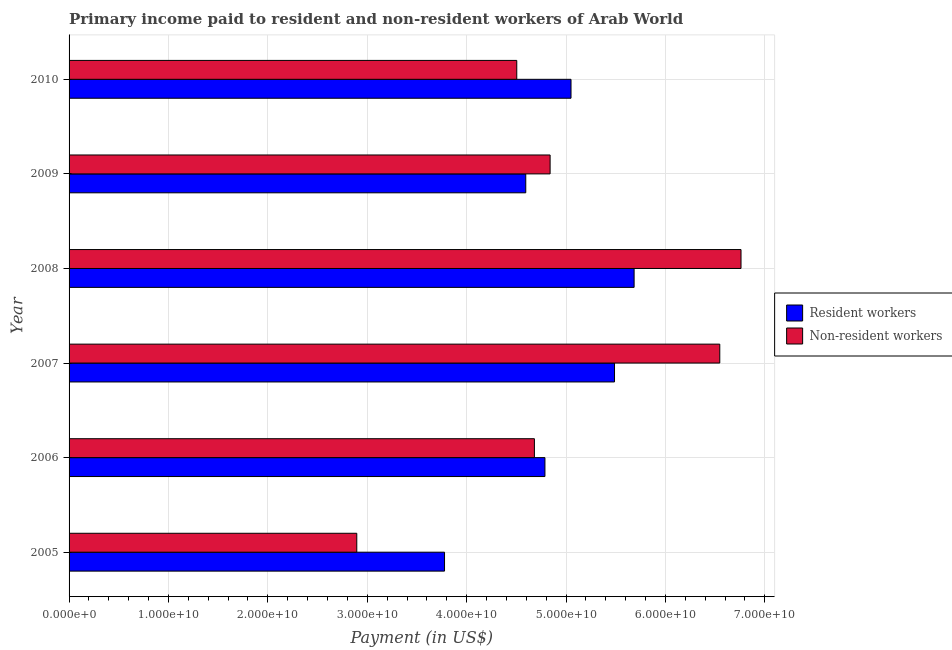How many groups of bars are there?
Offer a very short reply. 6. Are the number of bars on each tick of the Y-axis equal?
Give a very brief answer. Yes. What is the label of the 2nd group of bars from the top?
Give a very brief answer. 2009. What is the payment made to non-resident workers in 2009?
Offer a terse response. 4.84e+1. Across all years, what is the maximum payment made to resident workers?
Ensure brevity in your answer.  5.68e+1. Across all years, what is the minimum payment made to resident workers?
Keep it short and to the point. 3.78e+1. In which year was the payment made to resident workers maximum?
Offer a terse response. 2008. What is the total payment made to non-resident workers in the graph?
Your answer should be compact. 3.02e+11. What is the difference between the payment made to resident workers in 2006 and that in 2009?
Provide a short and direct response. 1.93e+09. What is the difference between the payment made to resident workers in 2008 and the payment made to non-resident workers in 2010?
Your response must be concise. 1.18e+1. What is the average payment made to non-resident workers per year?
Your response must be concise. 5.04e+1. In the year 2010, what is the difference between the payment made to resident workers and payment made to non-resident workers?
Ensure brevity in your answer.  5.46e+09. In how many years, is the payment made to resident workers greater than 12000000000 US$?
Ensure brevity in your answer.  6. What is the ratio of the payment made to resident workers in 2005 to that in 2008?
Ensure brevity in your answer.  0.66. What is the difference between the highest and the second highest payment made to resident workers?
Your answer should be very brief. 1.97e+09. What is the difference between the highest and the lowest payment made to resident workers?
Provide a succinct answer. 1.91e+1. In how many years, is the payment made to non-resident workers greater than the average payment made to non-resident workers taken over all years?
Ensure brevity in your answer.  2. Is the sum of the payment made to resident workers in 2005 and 2006 greater than the maximum payment made to non-resident workers across all years?
Keep it short and to the point. Yes. What does the 2nd bar from the top in 2008 represents?
Keep it short and to the point. Resident workers. What does the 1st bar from the bottom in 2010 represents?
Offer a very short reply. Resident workers. Are all the bars in the graph horizontal?
Offer a very short reply. Yes. What is the difference between two consecutive major ticks on the X-axis?
Make the answer very short. 1.00e+1. Does the graph contain any zero values?
Offer a very short reply. No. Where does the legend appear in the graph?
Offer a very short reply. Center right. What is the title of the graph?
Give a very brief answer. Primary income paid to resident and non-resident workers of Arab World. What is the label or title of the X-axis?
Make the answer very short. Payment (in US$). What is the label or title of the Y-axis?
Your answer should be compact. Year. What is the Payment (in US$) of Resident workers in 2005?
Your answer should be compact. 3.78e+1. What is the Payment (in US$) in Non-resident workers in 2005?
Provide a short and direct response. 2.89e+1. What is the Payment (in US$) of Resident workers in 2006?
Your answer should be very brief. 4.79e+1. What is the Payment (in US$) of Non-resident workers in 2006?
Provide a succinct answer. 4.68e+1. What is the Payment (in US$) of Resident workers in 2007?
Keep it short and to the point. 5.49e+1. What is the Payment (in US$) of Non-resident workers in 2007?
Your answer should be very brief. 6.55e+1. What is the Payment (in US$) in Resident workers in 2008?
Your answer should be compact. 5.68e+1. What is the Payment (in US$) of Non-resident workers in 2008?
Give a very brief answer. 6.76e+1. What is the Payment (in US$) in Resident workers in 2009?
Your response must be concise. 4.59e+1. What is the Payment (in US$) in Non-resident workers in 2009?
Ensure brevity in your answer.  4.84e+1. What is the Payment (in US$) of Resident workers in 2010?
Offer a terse response. 5.05e+1. What is the Payment (in US$) in Non-resident workers in 2010?
Keep it short and to the point. 4.50e+1. Across all years, what is the maximum Payment (in US$) of Resident workers?
Make the answer very short. 5.68e+1. Across all years, what is the maximum Payment (in US$) in Non-resident workers?
Provide a short and direct response. 6.76e+1. Across all years, what is the minimum Payment (in US$) of Resident workers?
Offer a very short reply. 3.78e+1. Across all years, what is the minimum Payment (in US$) of Non-resident workers?
Offer a terse response. 2.89e+1. What is the total Payment (in US$) in Resident workers in the graph?
Provide a succinct answer. 2.94e+11. What is the total Payment (in US$) of Non-resident workers in the graph?
Give a very brief answer. 3.02e+11. What is the difference between the Payment (in US$) of Resident workers in 2005 and that in 2006?
Make the answer very short. -1.01e+1. What is the difference between the Payment (in US$) of Non-resident workers in 2005 and that in 2006?
Your answer should be compact. -1.79e+1. What is the difference between the Payment (in US$) of Resident workers in 2005 and that in 2007?
Your response must be concise. -1.71e+1. What is the difference between the Payment (in US$) in Non-resident workers in 2005 and that in 2007?
Offer a very short reply. -3.65e+1. What is the difference between the Payment (in US$) of Resident workers in 2005 and that in 2008?
Offer a very short reply. -1.91e+1. What is the difference between the Payment (in US$) of Non-resident workers in 2005 and that in 2008?
Provide a short and direct response. -3.87e+1. What is the difference between the Payment (in US$) of Resident workers in 2005 and that in 2009?
Provide a succinct answer. -8.17e+09. What is the difference between the Payment (in US$) of Non-resident workers in 2005 and that in 2009?
Offer a very short reply. -1.95e+1. What is the difference between the Payment (in US$) in Resident workers in 2005 and that in 2010?
Your answer should be very brief. -1.27e+1. What is the difference between the Payment (in US$) of Non-resident workers in 2005 and that in 2010?
Provide a short and direct response. -1.61e+1. What is the difference between the Payment (in US$) of Resident workers in 2006 and that in 2007?
Your response must be concise. -7.00e+09. What is the difference between the Payment (in US$) in Non-resident workers in 2006 and that in 2007?
Offer a terse response. -1.86e+1. What is the difference between the Payment (in US$) of Resident workers in 2006 and that in 2008?
Offer a very short reply. -8.97e+09. What is the difference between the Payment (in US$) of Non-resident workers in 2006 and that in 2008?
Your answer should be very brief. -2.08e+1. What is the difference between the Payment (in US$) in Resident workers in 2006 and that in 2009?
Offer a terse response. 1.93e+09. What is the difference between the Payment (in US$) of Non-resident workers in 2006 and that in 2009?
Make the answer very short. -1.58e+09. What is the difference between the Payment (in US$) in Resident workers in 2006 and that in 2010?
Keep it short and to the point. -2.62e+09. What is the difference between the Payment (in US$) in Non-resident workers in 2006 and that in 2010?
Provide a short and direct response. 1.77e+09. What is the difference between the Payment (in US$) in Resident workers in 2007 and that in 2008?
Give a very brief answer. -1.97e+09. What is the difference between the Payment (in US$) in Non-resident workers in 2007 and that in 2008?
Offer a very short reply. -2.14e+09. What is the difference between the Payment (in US$) in Resident workers in 2007 and that in 2009?
Provide a succinct answer. 8.93e+09. What is the difference between the Payment (in US$) of Non-resident workers in 2007 and that in 2009?
Make the answer very short. 1.71e+1. What is the difference between the Payment (in US$) in Resident workers in 2007 and that in 2010?
Your response must be concise. 4.38e+09. What is the difference between the Payment (in US$) in Non-resident workers in 2007 and that in 2010?
Your response must be concise. 2.04e+1. What is the difference between the Payment (in US$) of Resident workers in 2008 and that in 2009?
Your answer should be compact. 1.09e+1. What is the difference between the Payment (in US$) in Non-resident workers in 2008 and that in 2009?
Ensure brevity in your answer.  1.92e+1. What is the difference between the Payment (in US$) in Resident workers in 2008 and that in 2010?
Your answer should be very brief. 6.35e+09. What is the difference between the Payment (in US$) of Non-resident workers in 2008 and that in 2010?
Provide a succinct answer. 2.26e+1. What is the difference between the Payment (in US$) of Resident workers in 2009 and that in 2010?
Ensure brevity in your answer.  -4.55e+09. What is the difference between the Payment (in US$) of Non-resident workers in 2009 and that in 2010?
Ensure brevity in your answer.  3.36e+09. What is the difference between the Payment (in US$) of Resident workers in 2005 and the Payment (in US$) of Non-resident workers in 2006?
Your response must be concise. -9.04e+09. What is the difference between the Payment (in US$) of Resident workers in 2005 and the Payment (in US$) of Non-resident workers in 2007?
Offer a very short reply. -2.77e+1. What is the difference between the Payment (in US$) of Resident workers in 2005 and the Payment (in US$) of Non-resident workers in 2008?
Provide a short and direct response. -2.98e+1. What is the difference between the Payment (in US$) in Resident workers in 2005 and the Payment (in US$) in Non-resident workers in 2009?
Ensure brevity in your answer.  -1.06e+1. What is the difference between the Payment (in US$) of Resident workers in 2005 and the Payment (in US$) of Non-resident workers in 2010?
Your answer should be very brief. -7.27e+09. What is the difference between the Payment (in US$) in Resident workers in 2006 and the Payment (in US$) in Non-resident workers in 2007?
Your response must be concise. -1.76e+1. What is the difference between the Payment (in US$) of Resident workers in 2006 and the Payment (in US$) of Non-resident workers in 2008?
Ensure brevity in your answer.  -1.97e+1. What is the difference between the Payment (in US$) in Resident workers in 2006 and the Payment (in US$) in Non-resident workers in 2009?
Keep it short and to the point. -5.21e+08. What is the difference between the Payment (in US$) of Resident workers in 2006 and the Payment (in US$) of Non-resident workers in 2010?
Provide a short and direct response. 2.83e+09. What is the difference between the Payment (in US$) in Resident workers in 2007 and the Payment (in US$) in Non-resident workers in 2008?
Keep it short and to the point. -1.27e+1. What is the difference between the Payment (in US$) of Resident workers in 2007 and the Payment (in US$) of Non-resident workers in 2009?
Give a very brief answer. 6.48e+09. What is the difference between the Payment (in US$) in Resident workers in 2007 and the Payment (in US$) in Non-resident workers in 2010?
Provide a short and direct response. 9.83e+09. What is the difference between the Payment (in US$) in Resident workers in 2008 and the Payment (in US$) in Non-resident workers in 2009?
Your answer should be compact. 8.45e+09. What is the difference between the Payment (in US$) of Resident workers in 2008 and the Payment (in US$) of Non-resident workers in 2010?
Make the answer very short. 1.18e+1. What is the difference between the Payment (in US$) of Resident workers in 2009 and the Payment (in US$) of Non-resident workers in 2010?
Your answer should be compact. 9.05e+08. What is the average Payment (in US$) in Resident workers per year?
Ensure brevity in your answer.  4.90e+1. What is the average Payment (in US$) in Non-resident workers per year?
Offer a terse response. 5.04e+1. In the year 2005, what is the difference between the Payment (in US$) in Resident workers and Payment (in US$) in Non-resident workers?
Your answer should be compact. 8.83e+09. In the year 2006, what is the difference between the Payment (in US$) of Resident workers and Payment (in US$) of Non-resident workers?
Offer a terse response. 1.06e+09. In the year 2007, what is the difference between the Payment (in US$) in Resident workers and Payment (in US$) in Non-resident workers?
Provide a succinct answer. -1.06e+1. In the year 2008, what is the difference between the Payment (in US$) of Resident workers and Payment (in US$) of Non-resident workers?
Give a very brief answer. -1.08e+1. In the year 2009, what is the difference between the Payment (in US$) in Resident workers and Payment (in US$) in Non-resident workers?
Ensure brevity in your answer.  -2.45e+09. In the year 2010, what is the difference between the Payment (in US$) in Resident workers and Payment (in US$) in Non-resident workers?
Provide a short and direct response. 5.46e+09. What is the ratio of the Payment (in US$) of Resident workers in 2005 to that in 2006?
Give a very brief answer. 0.79. What is the ratio of the Payment (in US$) of Non-resident workers in 2005 to that in 2006?
Offer a terse response. 0.62. What is the ratio of the Payment (in US$) of Resident workers in 2005 to that in 2007?
Offer a terse response. 0.69. What is the ratio of the Payment (in US$) of Non-resident workers in 2005 to that in 2007?
Give a very brief answer. 0.44. What is the ratio of the Payment (in US$) of Resident workers in 2005 to that in 2008?
Offer a terse response. 0.66. What is the ratio of the Payment (in US$) of Non-resident workers in 2005 to that in 2008?
Provide a succinct answer. 0.43. What is the ratio of the Payment (in US$) of Resident workers in 2005 to that in 2009?
Your answer should be compact. 0.82. What is the ratio of the Payment (in US$) of Non-resident workers in 2005 to that in 2009?
Your response must be concise. 0.6. What is the ratio of the Payment (in US$) of Resident workers in 2005 to that in 2010?
Make the answer very short. 0.75. What is the ratio of the Payment (in US$) in Non-resident workers in 2005 to that in 2010?
Ensure brevity in your answer.  0.64. What is the ratio of the Payment (in US$) of Resident workers in 2006 to that in 2007?
Give a very brief answer. 0.87. What is the ratio of the Payment (in US$) of Non-resident workers in 2006 to that in 2007?
Offer a terse response. 0.72. What is the ratio of the Payment (in US$) of Resident workers in 2006 to that in 2008?
Give a very brief answer. 0.84. What is the ratio of the Payment (in US$) of Non-resident workers in 2006 to that in 2008?
Provide a succinct answer. 0.69. What is the ratio of the Payment (in US$) in Resident workers in 2006 to that in 2009?
Your answer should be compact. 1.04. What is the ratio of the Payment (in US$) in Non-resident workers in 2006 to that in 2009?
Your answer should be very brief. 0.97. What is the ratio of the Payment (in US$) of Resident workers in 2006 to that in 2010?
Provide a short and direct response. 0.95. What is the ratio of the Payment (in US$) in Non-resident workers in 2006 to that in 2010?
Your response must be concise. 1.04. What is the ratio of the Payment (in US$) in Resident workers in 2007 to that in 2008?
Provide a short and direct response. 0.97. What is the ratio of the Payment (in US$) of Non-resident workers in 2007 to that in 2008?
Offer a terse response. 0.97. What is the ratio of the Payment (in US$) of Resident workers in 2007 to that in 2009?
Your response must be concise. 1.19. What is the ratio of the Payment (in US$) of Non-resident workers in 2007 to that in 2009?
Keep it short and to the point. 1.35. What is the ratio of the Payment (in US$) in Resident workers in 2007 to that in 2010?
Ensure brevity in your answer.  1.09. What is the ratio of the Payment (in US$) in Non-resident workers in 2007 to that in 2010?
Offer a very short reply. 1.45. What is the ratio of the Payment (in US$) of Resident workers in 2008 to that in 2009?
Your answer should be very brief. 1.24. What is the ratio of the Payment (in US$) in Non-resident workers in 2008 to that in 2009?
Your answer should be very brief. 1.4. What is the ratio of the Payment (in US$) in Resident workers in 2008 to that in 2010?
Your response must be concise. 1.13. What is the ratio of the Payment (in US$) in Non-resident workers in 2008 to that in 2010?
Offer a very short reply. 1.5. What is the ratio of the Payment (in US$) of Resident workers in 2009 to that in 2010?
Your answer should be compact. 0.91. What is the ratio of the Payment (in US$) in Non-resident workers in 2009 to that in 2010?
Your answer should be compact. 1.07. What is the difference between the highest and the second highest Payment (in US$) of Resident workers?
Your answer should be compact. 1.97e+09. What is the difference between the highest and the second highest Payment (in US$) in Non-resident workers?
Keep it short and to the point. 2.14e+09. What is the difference between the highest and the lowest Payment (in US$) of Resident workers?
Give a very brief answer. 1.91e+1. What is the difference between the highest and the lowest Payment (in US$) in Non-resident workers?
Give a very brief answer. 3.87e+1. 